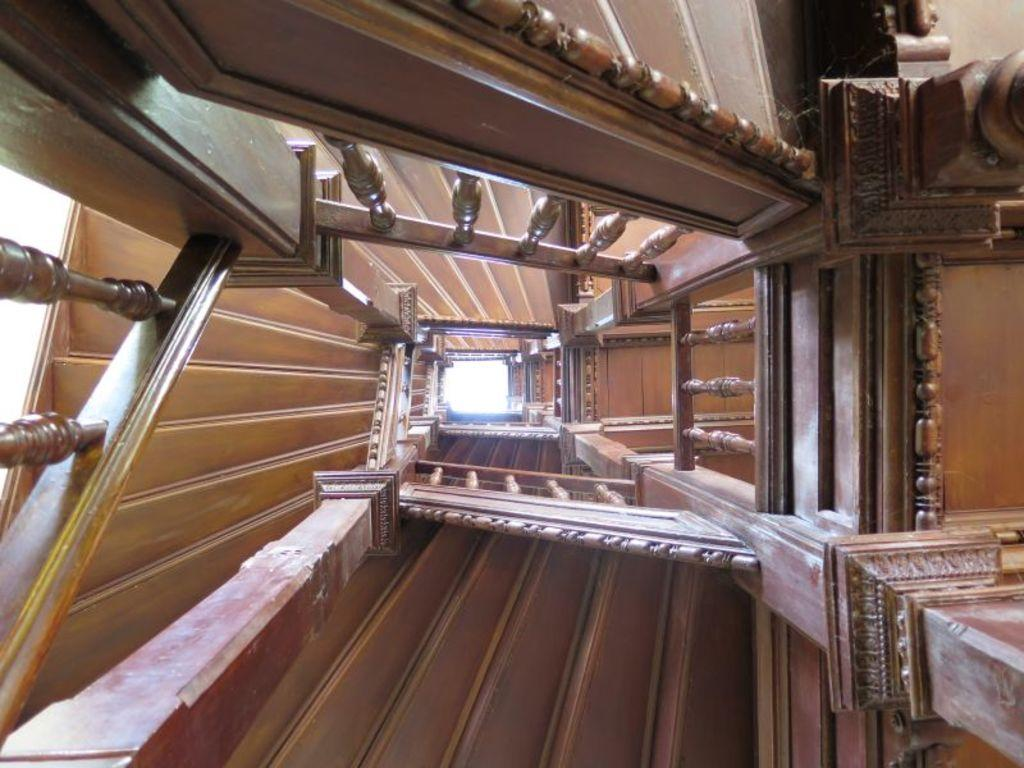What type of staircase is visible in the image? There is a wooden staircase in the image. What type of blade is being sharpened on the wooden staircase in the image? There is no blade or sharpening activity present in the image; it only features a wooden staircase. 